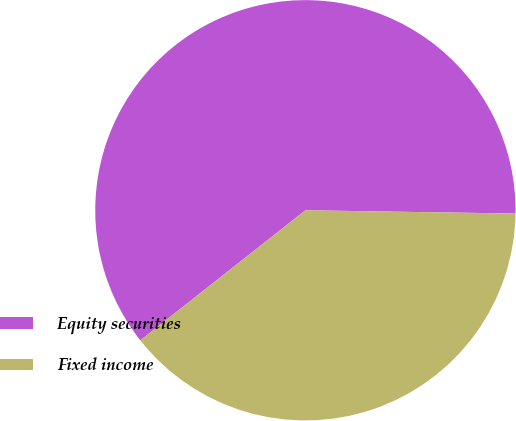<chart> <loc_0><loc_0><loc_500><loc_500><pie_chart><fcel>Equity securities<fcel>Fixed income<nl><fcel>60.87%<fcel>39.13%<nl></chart> 